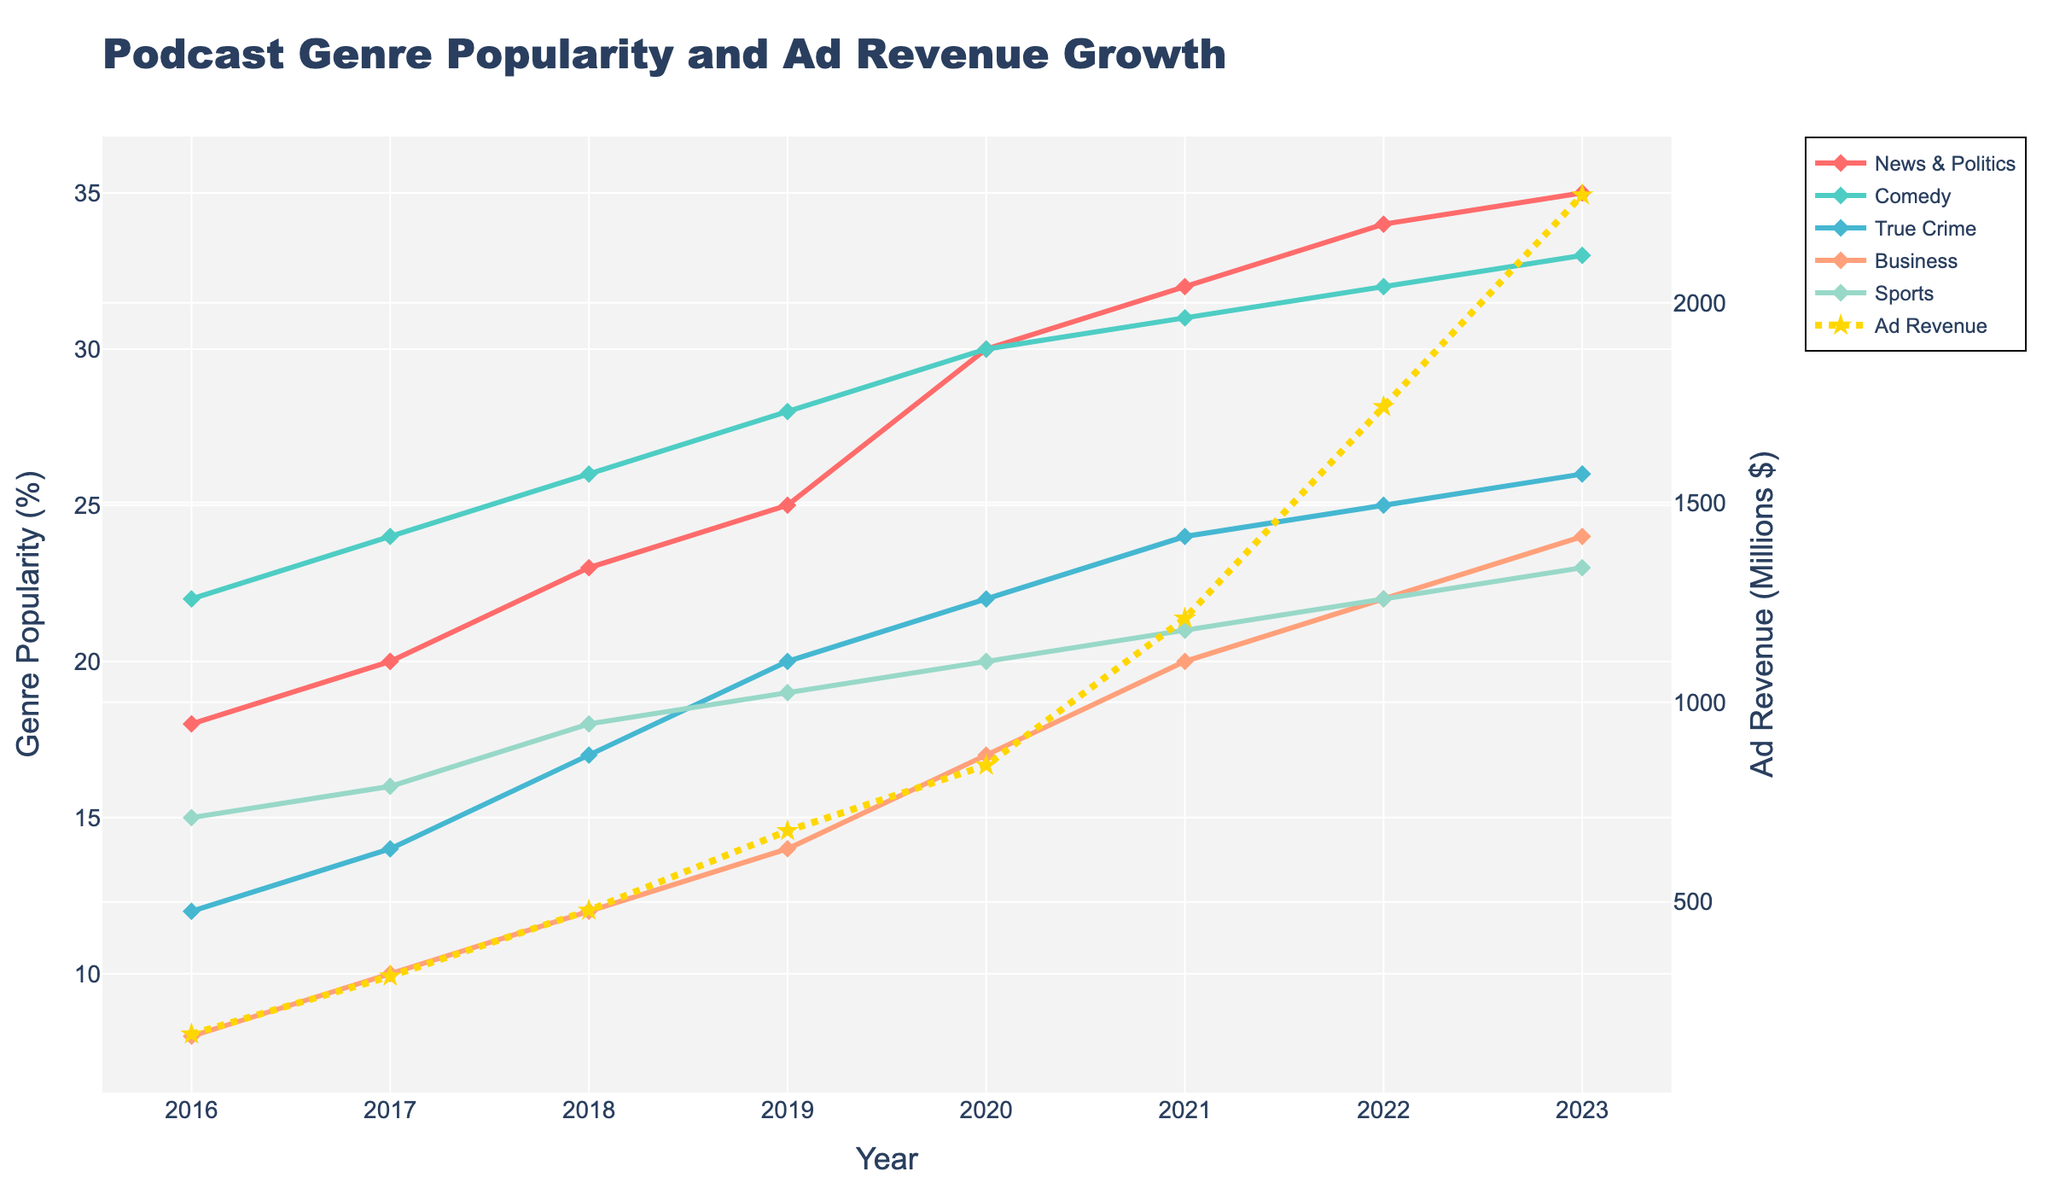What trend can you observe in the ad revenue from 2016 to 2023? The ad revenue increases steadily from 169 million dollars in 2016 to 2270 million dollars in 2023. Each year shows a significant rise.
Answer: Steady increase Which podcast genre saw the highest growth in popularity from 2016 to 2023? To determine the highest growth, we calculate the difference in percentage points for each genre between the years 2016 and 2023. News & Politics grew by 17 percentage points, Comedy by 11, True Crime by 14, Business by 16, and Sports by 8.
Answer: News & Politics What was the total percentage popularity of News & Politics and True Crime in 2023? Adding the popularity percentages of News & Politics (35%) and True Crime (26%) for the year 2023.
Answer: 61% How did the popularity of the Comedy genre change between 2016 and 2023? The popularity of Comedy increased from 22% in 2016 to 33% in 2023. The difference is 33% - 22% = 11%.
Answer: Increased by 11% Which year saw the biggest increase in ad revenue and by how much? Calculate the yearly differences in ad revenue and find the year with the maximum difference. From 2021 to 2022, the increase was 1740 - 1210 = 530 million dollars, which is the largest jump.
Answer: 2022, 530 million dollars By what percentage did the popularity of Sports podcasts increase from 2016 to 2023? Calculate the percentage increase = ((23 - 15) / 15) * 100.
Answer: 53.3% Which genre consistently increased in popularity every year from 2016 to 2023? Checking each genre's popularity year by year, News & Politics consistently rises each year without any decrease.
Answer: News & Politics What was the range of ad revenue growth from 2016 to 2023? Find the difference between the highest and lowest values of ad revenue over the years. The range is 2270 million dollars (2023) - 169 million dollars (2016) = 2101 million dollars.
Answer: 2101 million dollars In which year did the Business genre's popularity see its highest single-year increase? Comparing year-over-year changes for Business: 
2017: 10 - 8 = 2 
2018: 12 - 10 = 2 
2019: 14 - 12 = 2 
2020: 17 - 14 = 3 
2021: 20 - 17 = 3 
2022: 22 - 20 = 2 
2023: 24 - 22 = 2 
The highest single-year increase is in 2020 and 2021 (both by 3%).
Answer: 2020 and 2021 How does the 2023 popularity of Sports compare to the 2023 popularity of True Crime? By looking at the 2023 data, Sports has a 23% popularity, whereas True Crime has 26%. True Crime is more popular by 3 percentage points.
Answer: True Crime is more popular by 3 percentage points 